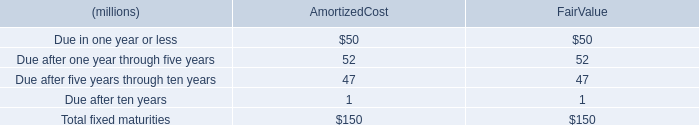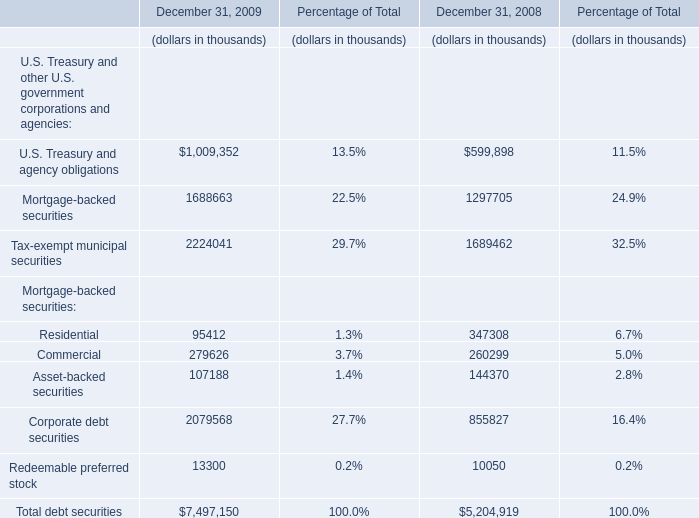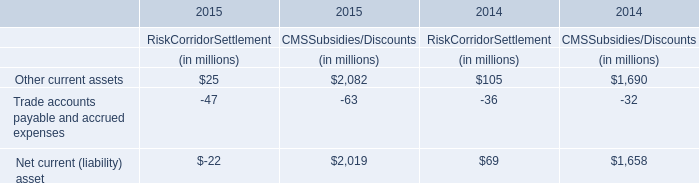What will Commercial be like in 2010 if it develops with the same increasing rate as current? (in thousand) 
Computations: ((((279626 - 260299) / 260299) + 1) * 279626)
Answer: 300388.01484. 